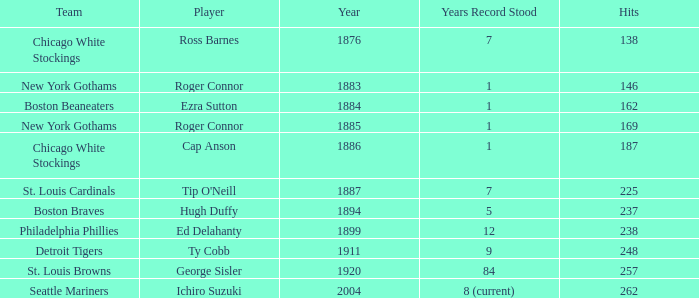Name the player with 238 hits and years after 1885 Ed Delahanty. Would you be able to parse every entry in this table? {'header': ['Team', 'Player', 'Year', 'Years Record Stood', 'Hits'], 'rows': [['Chicago White Stockings', 'Ross Barnes', '1876', '7', '138'], ['New York Gothams', 'Roger Connor', '1883', '1', '146'], ['Boston Beaneaters', 'Ezra Sutton', '1884', '1', '162'], ['New York Gothams', 'Roger Connor', '1885', '1', '169'], ['Chicago White Stockings', 'Cap Anson', '1886', '1', '187'], ['St. Louis Cardinals', "Tip O'Neill", '1887', '7', '225'], ['Boston Braves', 'Hugh Duffy', '1894', '5', '237'], ['Philadelphia Phillies', 'Ed Delahanty', '1899', '12', '238'], ['Detroit Tigers', 'Ty Cobb', '1911', '9', '248'], ['St. Louis Browns', 'George Sisler', '1920', '84', '257'], ['Seattle Mariners', 'Ichiro Suzuki', '2004', '8 (current)', '262']]} 